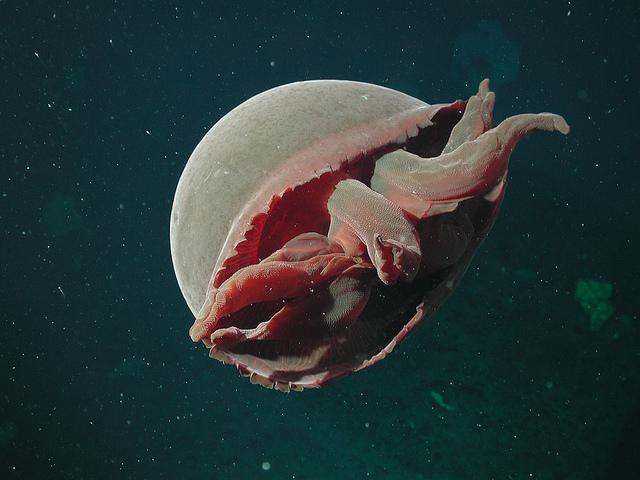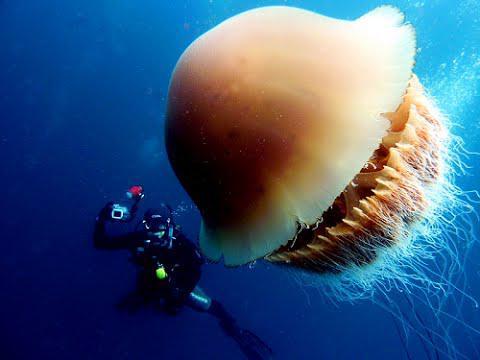The first image is the image on the left, the second image is the image on the right. Analyze the images presented: Is the assertion "One image shows a person in a scuba suit holding something up next to a large mushroom-capped jellyfish with its tentacles trailing diagonally downward to the right." valid? Answer yes or no. Yes. The first image is the image on the left, the second image is the image on the right. For the images displayed, is the sentence "One image in the pair shows a single jellyfish and the other shows a scuba diver with a single jellyfish." factually correct? Answer yes or no. Yes. 